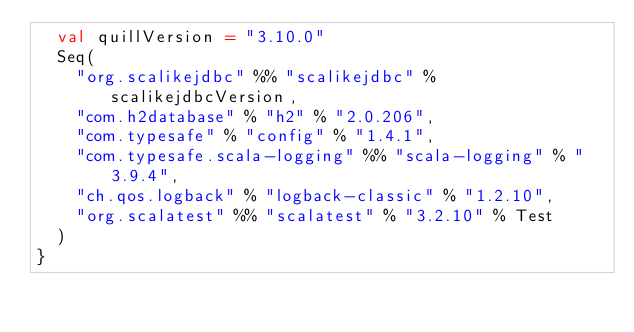<code> <loc_0><loc_0><loc_500><loc_500><_Scala_>  val quillVersion = "3.10.0"
  Seq(
    "org.scalikejdbc" %% "scalikejdbc" % scalikejdbcVersion,
    "com.h2database" % "h2" % "2.0.206",
    "com.typesafe" % "config" % "1.4.1",
    "com.typesafe.scala-logging" %% "scala-logging" % "3.9.4",
    "ch.qos.logback" % "logback-classic" % "1.2.10",
    "org.scalatest" %% "scalatest" % "3.2.10" % Test
  )
}
</code> 